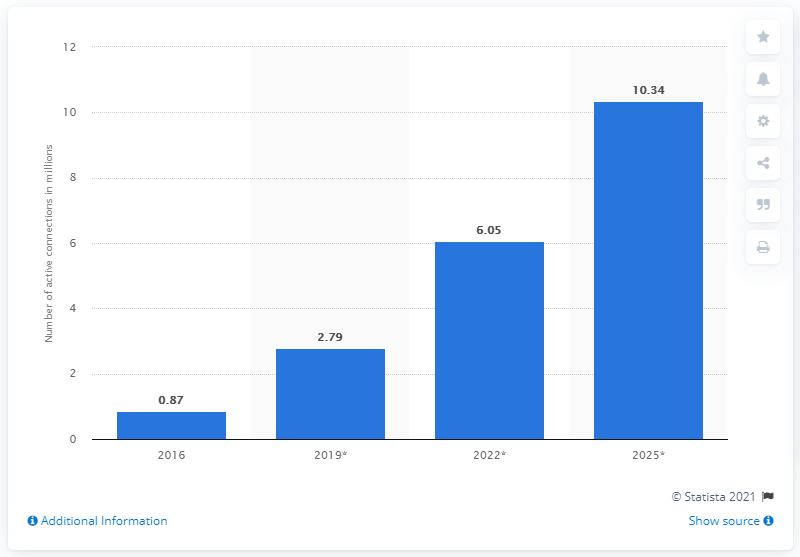Outline some significant characteristics in this image. In 2016, the number of active connections in the healthcare sector of the Internet of Things (IoT) was 0.87 billion. According to estimates, the number of active connections in the healthcare sector of the Internet of Things (IoT) was expected to reach 10.34 billion by 2025. 